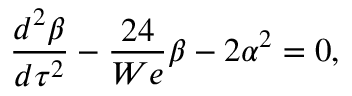Convert formula to latex. <formula><loc_0><loc_0><loc_500><loc_500>\frac { d ^ { 2 } \beta } { d \tau ^ { 2 } } - \frac { 2 4 } { W e } \beta - 2 \alpha ^ { 2 } = 0 ,</formula> 